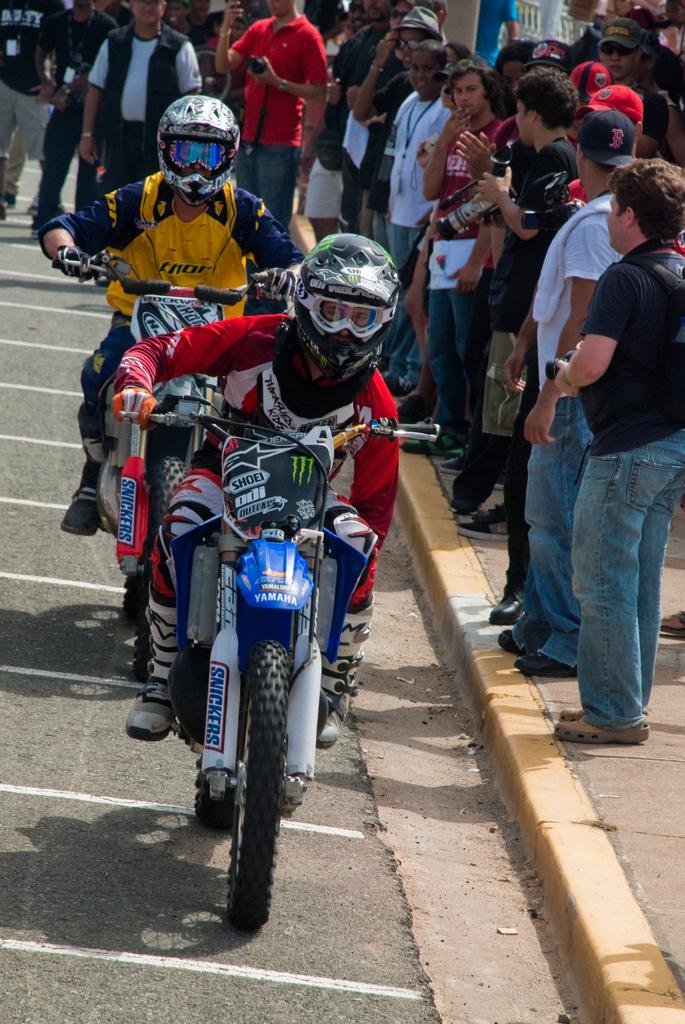What are the two men in the image doing? The two men in the image are riding bikes. Where are the men riding their bikes? The men are on a road. Can you describe the background of the image? There are people visible in the background of the image. Where is the playground located in the image? There is no playground present in the image. What type of bean is being used by the men to ride their bikes? The men are not using any beans to ride their bikes; they are riding regular bicycles. 